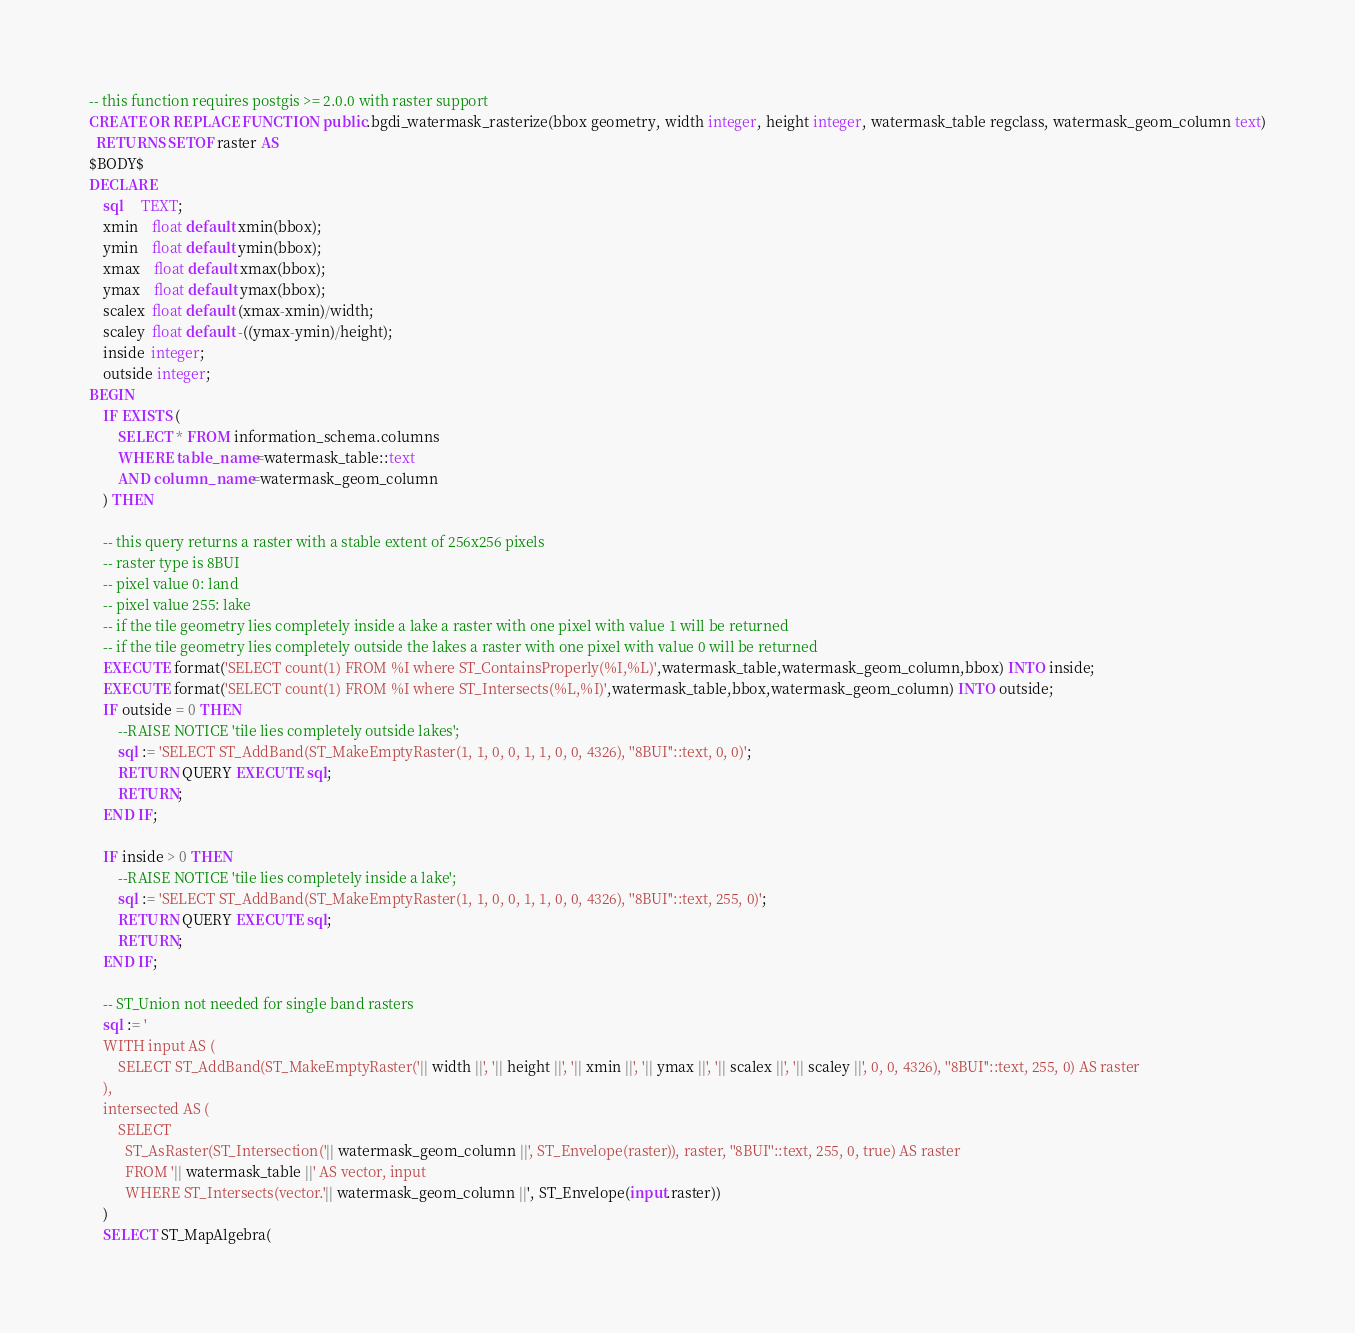Convert code to text. <code><loc_0><loc_0><loc_500><loc_500><_SQL_>-- this function requires postgis >= 2.0.0 with raster support
CREATE OR REPLACE FUNCTION public.bgdi_watermask_rasterize(bbox geometry, width integer, height integer, watermask_table regclass, watermask_geom_column text)
  RETURNS SETOF raster AS
$BODY$
DECLARE 
    sql     TEXT;
    xmin    float default xmin(bbox);
    ymin    float default ymin(bbox);
    xmax    float default xmax(bbox);
    ymax    float default ymax(bbox);
    scalex  float default (xmax-xmin)/width;
    scaley  float default -((ymax-ymin)/height);
    inside  integer;
    outside integer;
BEGIN
    IF EXISTS (
        SELECT * FROM information_schema.columns
        WHERE table_name=watermask_table::text
        AND column_name=watermask_geom_column
    ) THEN

    -- this query returns a raster with a stable extent of 256x256 pixels
    -- raster type is 8BUI
    -- pixel value 0: land
    -- pixel value 255: lake
    -- if the tile geometry lies completely inside a lake a raster with one pixel with value 1 will be returned
    -- if the tile geometry lies completely outside the lakes a raster with one pixel with value 0 will be returned
    EXECUTE format('SELECT count(1) FROM %I where ST_ContainsProperly(%I,%L)',watermask_table,watermask_geom_column,bbox) INTO inside;
    EXECUTE format('SELECT count(1) FROM %I where ST_Intersects(%L,%I)',watermask_table,bbox,watermask_geom_column) INTO outside;
    IF outside = 0 THEN
        --RAISE NOTICE 'tile lies completely outside lakes';
        sql := 'SELECT ST_AddBand(ST_MakeEmptyRaster(1, 1, 0, 0, 1, 1, 0, 0, 4326), ''8BUI''::text, 0, 0)';
        RETURN QUERY EXECUTE sql;
        RETURN;
    END IF;

    IF inside > 0 THEN
        --RAISE NOTICE 'tile lies completely inside a lake';
        sql := 'SELECT ST_AddBand(ST_MakeEmptyRaster(1, 1, 0, 0, 1, 1, 0, 0, 4326), ''8BUI''::text, 255, 0)';
        RETURN QUERY EXECUTE sql;
        RETURN;
    END IF;

    -- ST_Union not needed for single band rasters
    sql := '
    WITH input AS (
        SELECT ST_AddBand(ST_MakeEmptyRaster('|| width ||', '|| height ||', '|| xmin ||', '|| ymax ||', '|| scalex ||', '|| scaley ||', 0, 0, 4326), ''8BUI''::text, 255, 0) AS raster
    ),
    intersected AS (
        SELECT
          ST_AsRaster(ST_Intersection('|| watermask_geom_column ||', ST_Envelope(raster)), raster, ''8BUI''::text, 255, 0, true) AS raster
          FROM '|| watermask_table ||' AS vector, input
          WHERE ST_Intersects(vector.'|| watermask_geom_column ||', ST_Envelope(input.raster))
    )
    SELECT ST_MapAlgebra(</code> 